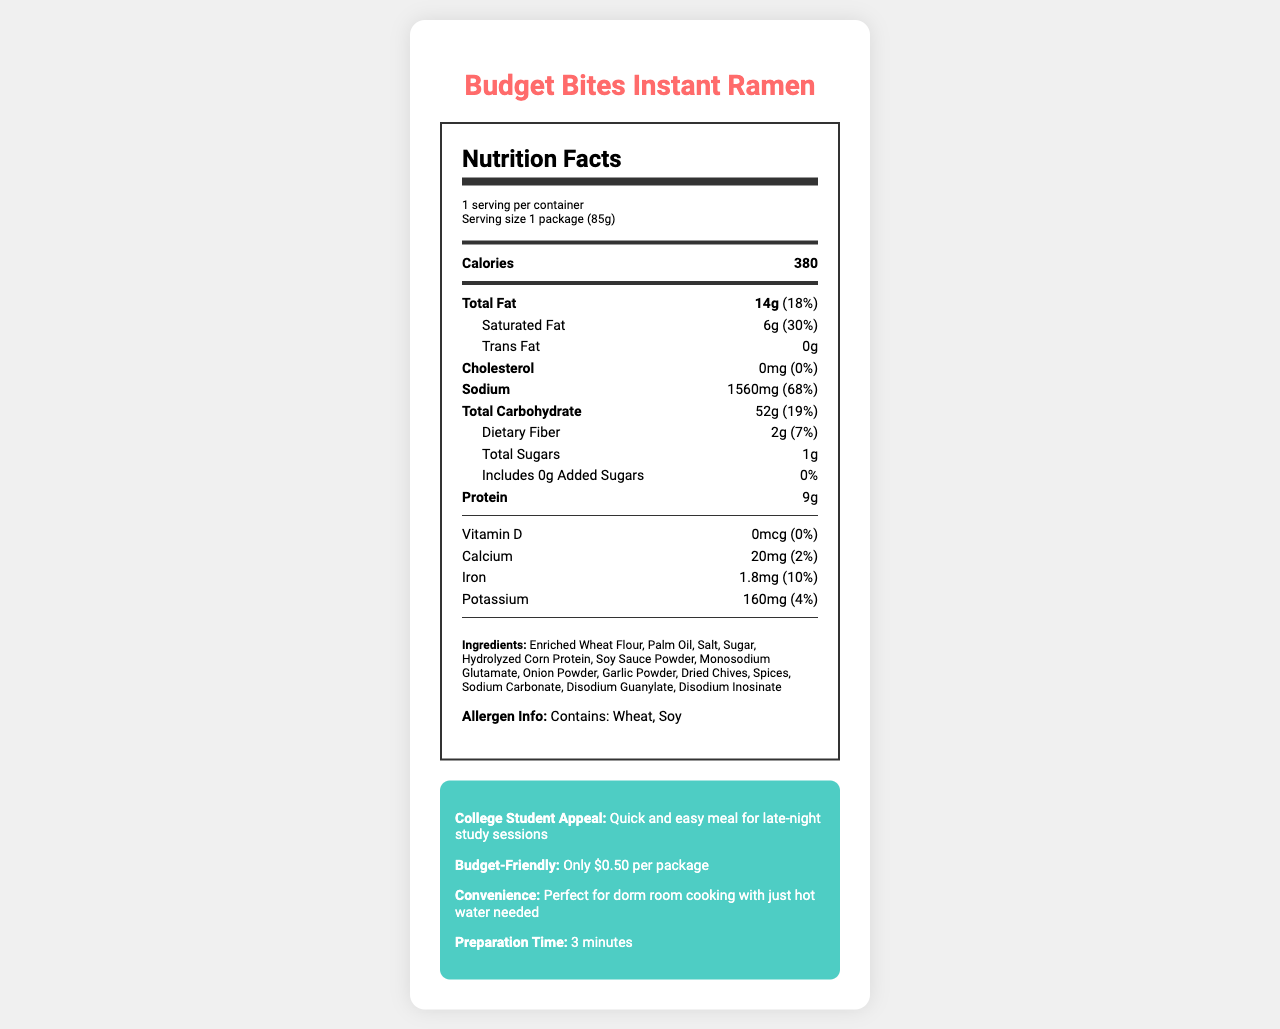What is the serving size of the Budget Bites Instant Ramen? The document states that the serving size is 1 package (85g).
Answer: 1 package (85g) How many calories are in one serving? The nutrition label indicates that there are 380 calories in one serving.
Answer: 380 What is the total amount of saturated fat in one serving? The document states that one serving contains 6g of saturated fat.
Answer: 6g How much sodium is in one serving? The nutrition label lists the sodium content as 1560mg per serving, which is 68% of the daily value.
Answer: 1560mg What is the preparation time for the Budget Bites Instant Ramen? The document indicates that the preparation time is 3 minutes.
Answer: 3 minutes Which of the following is an ingredient in Budget Bites Instant Ramen? A. Maltodextrin B. Dried Chives C. Corn Starch D. Whey Protein The document lists Dried Chives as one of the ingredients.
Answer: B What percentage of the daily value of saturated fat does one serving contain? A. 10% B. 20% C. 30% D. 40% The document states that the daily value of saturated fat in one serving is 30%.
Answer: C Does the product contain any trans fat? The nutrition label indicates that there are 0g of trans fat.
Answer: No What is the main appeal of this product for college students? The document highlights that it is a quick and easy meal for late-night study sessions.
Answer: Quick and easy meal for late-night study sessions Summarize the main nutritional content of Budget Bites Instant Ramen. This summary covers the key nutritional contents as listed in the document, providing a concise description of the important dietary components.
Answer: The Budget Bites Instant Ramen provides 380 calories per serving, with 14g of total fat (18% of daily value), 6g of saturated fat (30% of daily value), 0g of trans fat, 0mg of cholesterol, 1560mg of sodium (68% of daily value), 52g of total carbohydrates (19% of daily value), 2g of dietary fiber (7% of daily value), and 9g of protein. It contains small amounts of vitamin D, calcium, iron, and potassium. What is the daily value percentage of dietary fiber in one serving? The document states that one serving contains 2g of dietary fiber, which is 7% of the daily value.
Answer: 7% How much calcium does one serving provide? The nutrition label indicates that there is 20mg of calcium in one serving.
Answer: 20mg Does the Budget Bites Instant Ramen contain any added sugars? The document specifies that there are 0g of added sugars in one serving.
Answer: No Is this product a good source of iron? The document indicates that one serving contains 1.8mg of iron, which is 10% of the daily value.
Answer: Yes What type of cooking is required for this product? The document mentions that it is perfect for dorm room cooking with just hot water needed.
Answer: Hot water Is there any information about the shelf life of the product? The document provides storage instructions but does not mention the shelf life of the product.
Answer: Not enough information What are the allergens present in this product? The allergen information in the document states that the product contains wheat and soy.
Answer: Wheat, Soy Is the product budget-friendly? The document specifies that the product is budget-friendly, costing only $0.50 per package.
Answer: Yes 